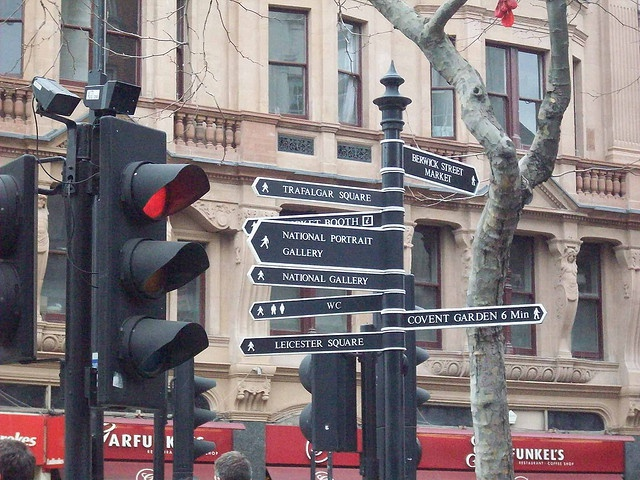Describe the objects in this image and their specific colors. I can see traffic light in gray, black, and darkblue tones, traffic light in gray and black tones, traffic light in gray, black, and darkblue tones, traffic light in gray, black, and darkblue tones, and people in gray and black tones in this image. 